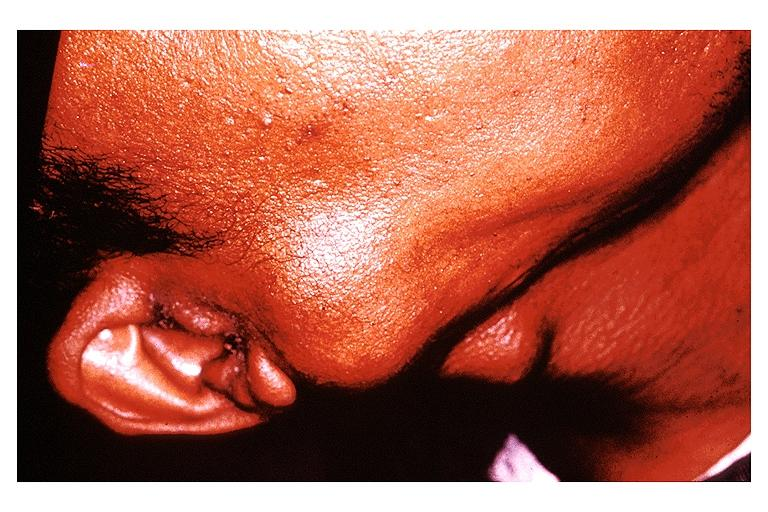what is present?
Answer the question using a single word or phrase. Oral 